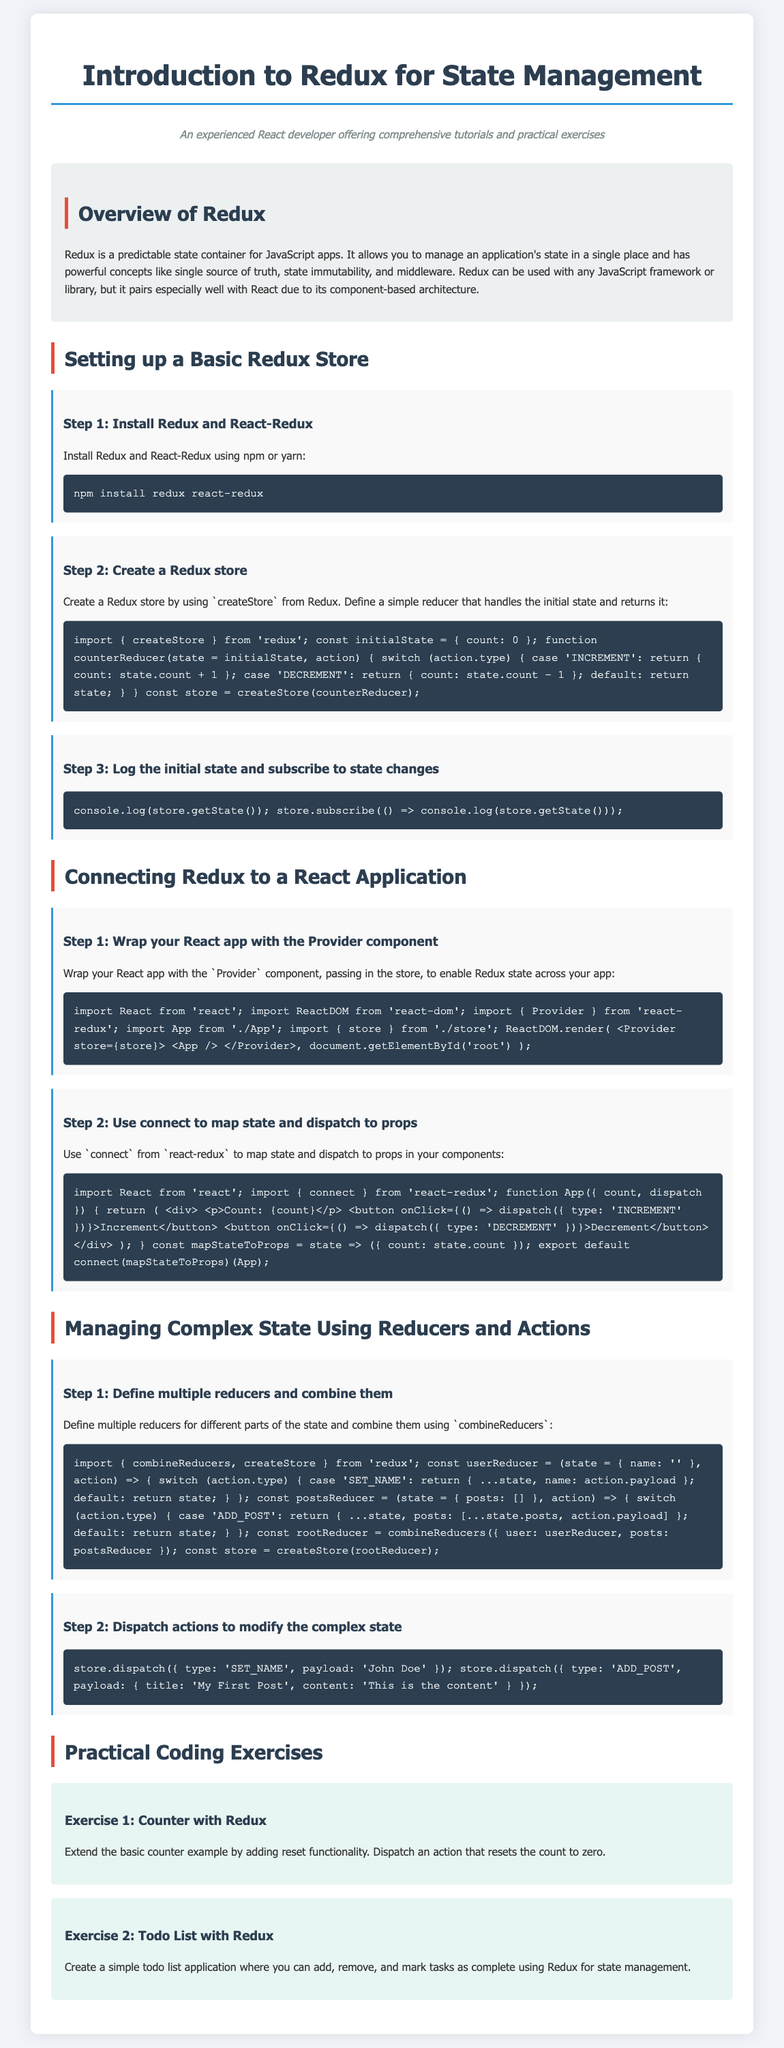What is Redux? Redux is a predictable state container for JavaScript apps.
Answer: predictable state container What command is used to install Redux and React-Redux? The command to install both libraries is provided in the document.
Answer: npm install redux react-redux What is the initial state defined in the example reducer? The initial state is defined in the counter reducer example.
Answer: count: 0 What is the role of the Provider component in a React application? The Provider component wraps the React app to enable Redux state across the app.
Answer: enable Redux state How do you log the initial state of the Redux store? The method used to log the initial state is shown in the document.
Answer: console.log(store.getState()) What function is used to combine multiple reducers? The function that combines multiple reducers is mentioned in the lesson.
Answer: combineReducers What type of action is dispatched to set a user's name? The action type needed to update the user's name is described in the example.
Answer: SET_NAME What is the first practical coding exercise mentioned? The document specifies the first exercise for practical coding.
Answer: Counter with Redux How many coding exercises are provided in the document? The document lists the number of coding exercises included.
Answer: two 